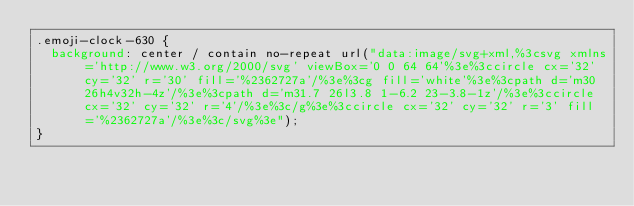Convert code to text. <code><loc_0><loc_0><loc_500><loc_500><_CSS_>.emoji-clock-630 {
  background: center / contain no-repeat url("data:image/svg+xml,%3csvg xmlns='http://www.w3.org/2000/svg' viewBox='0 0 64 64'%3e%3ccircle cx='32' cy='32' r='30' fill='%2362727a'/%3e%3cg fill='white'%3e%3cpath d='m30 26h4v32h-4z'/%3e%3cpath d='m31.7 26l3.8 1-6.2 23-3.8-1z'/%3e%3ccircle cx='32' cy='32' r='4'/%3e%3c/g%3e%3ccircle cx='32' cy='32' r='3' fill='%2362727a'/%3e%3c/svg%3e");
}</code> 